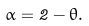<formula> <loc_0><loc_0><loc_500><loc_500>\alpha = 2 - \theta .</formula> 